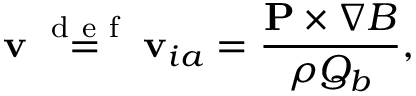<formula> <loc_0><loc_0><loc_500><loc_500>{ v } \stackrel { d e f } { = } { v } _ { i a } = \frac { { P } \times \nabla B } { \rho Q _ { b } } ,</formula> 